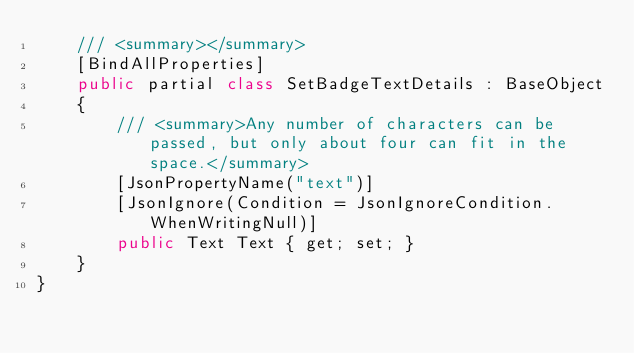<code> <loc_0><loc_0><loc_500><loc_500><_C#_>    /// <summary></summary>
    [BindAllProperties]
    public partial class SetBadgeTextDetails : BaseObject
    {
        /// <summary>Any number of characters can be passed, but only about four can fit in the space.</summary>
        [JsonPropertyName("text")]
        [JsonIgnore(Condition = JsonIgnoreCondition.WhenWritingNull)]
        public Text Text { get; set; }
    }
}
</code> 